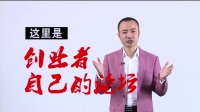What does the expression on the man's face suggest about his role or the context of this image? The man's expression is welcoming, combined with his gesture of outstretched hands, which generally signifies openness and a desire to engage with the viewer. This demeanor is often associated with individuals in roles that involve public speaking, teaching, or presenting. Given the setting and his attire, it's plausible that he is a host of a show, a speaker at an event, or a professional delivering a structured message meant to captivate an audience. 